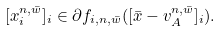Convert formula to latex. <formula><loc_0><loc_0><loc_500><loc_500>[ { x } _ { i } ^ { n , \bar { w } } ] _ { i } \in \partial f _ { i , n , \bar { w } } ( [ \bar { x } - { v } _ { A } ^ { n , \bar { w } } ] _ { i } ) .</formula> 